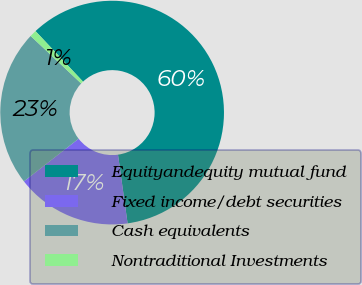Convert chart to OTSL. <chart><loc_0><loc_0><loc_500><loc_500><pie_chart><fcel>Equityandequity mutual fund<fcel>Fixed income/debt securities<fcel>Cash equivalents<fcel>Nontraditional Investments<nl><fcel>59.8%<fcel>16.67%<fcel>22.55%<fcel>0.98%<nl></chart> 